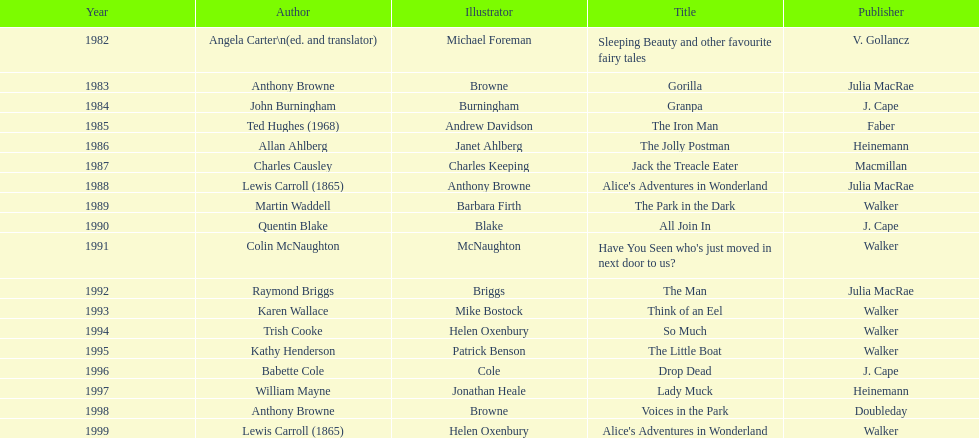How many complete titles has walker published? 5. 